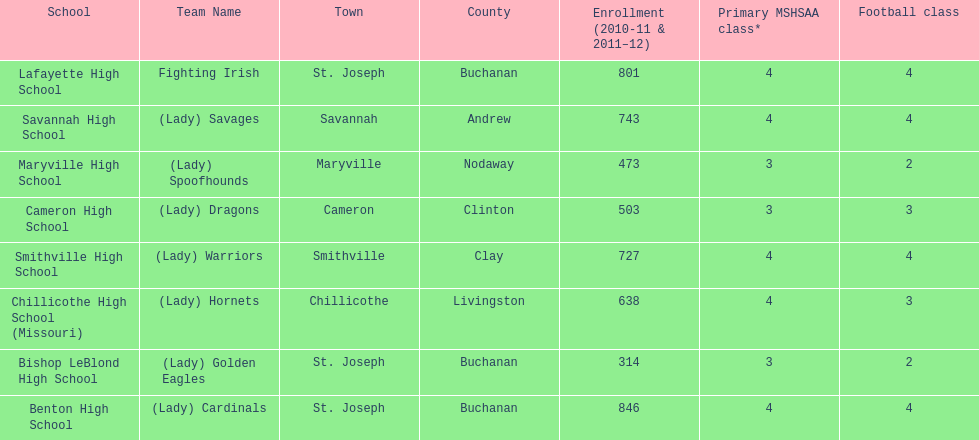Which school has the least amount of student enrollment between 2010-2011 and 2011-2012? Bishop LeBlond High School. 